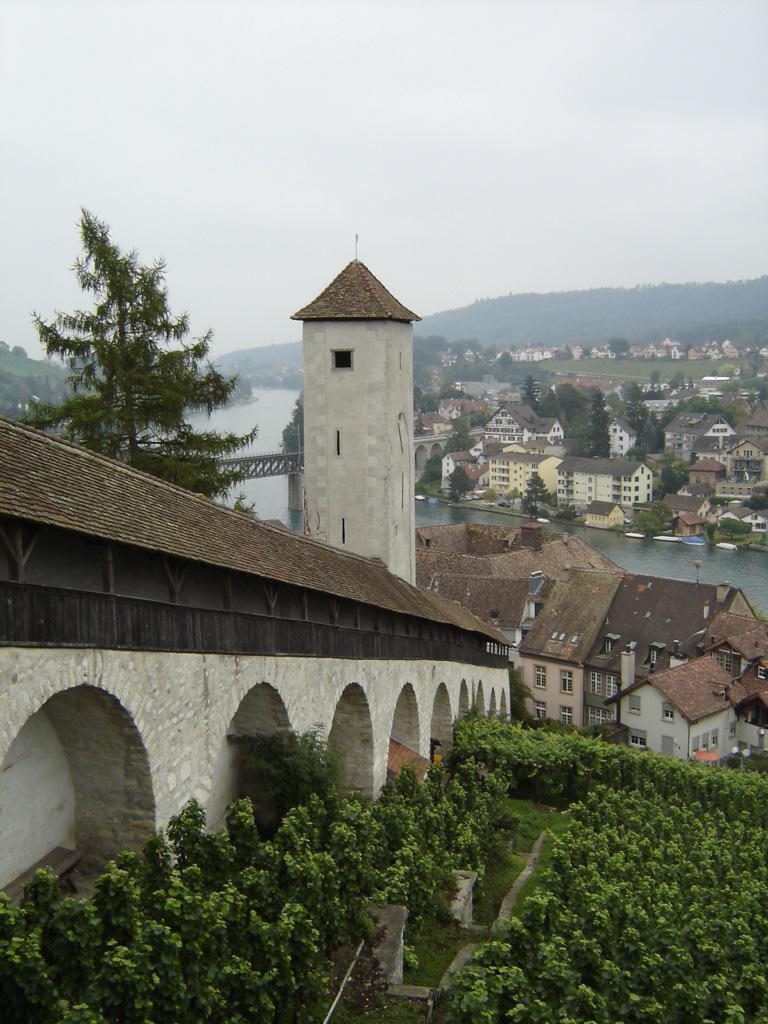In one or two sentences, can you explain what this image depicts? In this picture we can see plants on the ground and in the background we can see a bridgewater, houses, trees, mountains and the sky. 